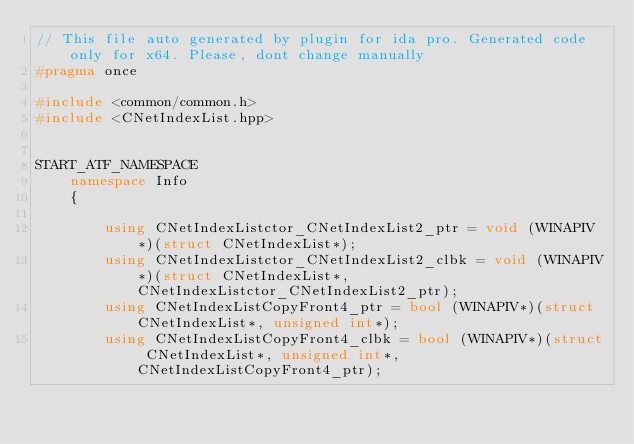<code> <loc_0><loc_0><loc_500><loc_500><_C++_>// This file auto generated by plugin for ida pro. Generated code only for x64. Please, dont change manually
#pragma once

#include <common/common.h>
#include <CNetIndexList.hpp>


START_ATF_NAMESPACE
    namespace Info
    {
        
        using CNetIndexListctor_CNetIndexList2_ptr = void (WINAPIV*)(struct CNetIndexList*);
        using CNetIndexListctor_CNetIndexList2_clbk = void (WINAPIV*)(struct CNetIndexList*, CNetIndexListctor_CNetIndexList2_ptr);
        using CNetIndexListCopyFront4_ptr = bool (WINAPIV*)(struct CNetIndexList*, unsigned int*);
        using CNetIndexListCopyFront4_clbk = bool (WINAPIV*)(struct CNetIndexList*, unsigned int*, CNetIndexListCopyFront4_ptr);</code> 